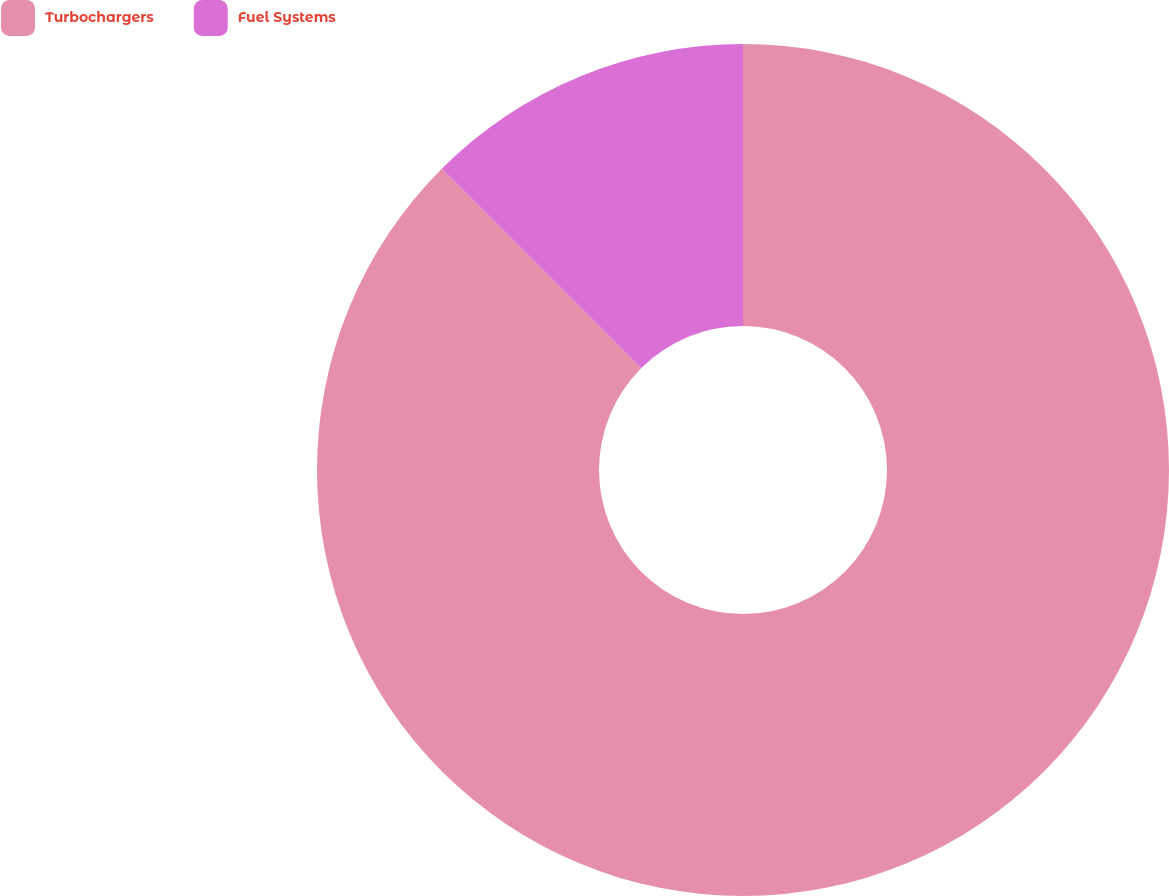<chart> <loc_0><loc_0><loc_500><loc_500><pie_chart><fcel>Turbochargers<fcel>Fuel Systems<nl><fcel>87.5%<fcel>12.5%<nl></chart> 